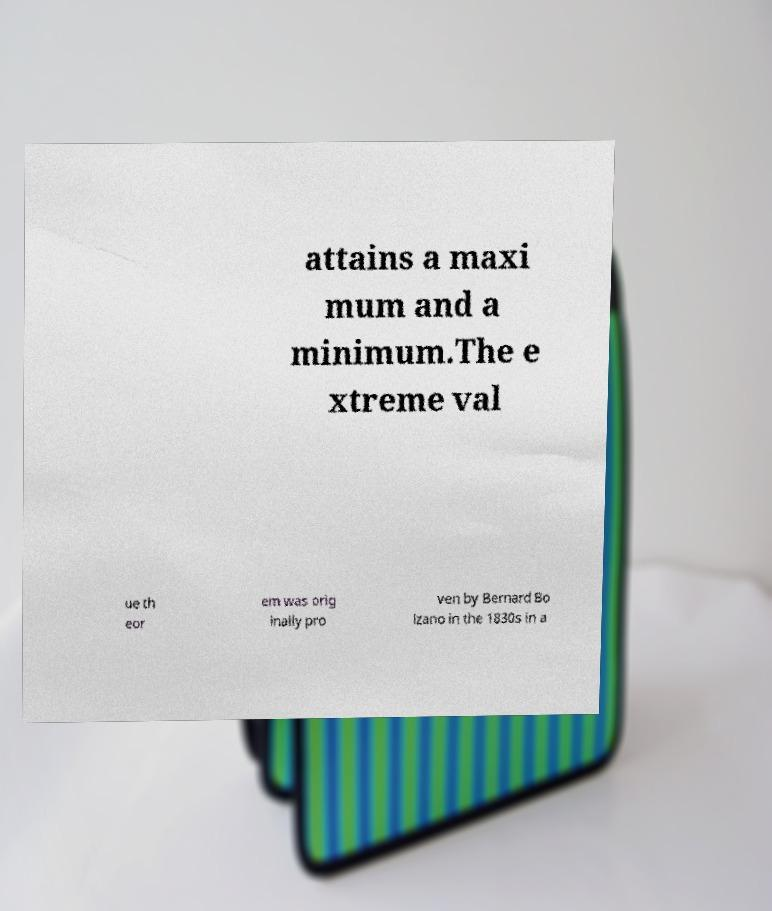Could you extract and type out the text from this image? attains a maxi mum and a minimum.The e xtreme val ue th eor em was orig inally pro ven by Bernard Bo lzano in the 1830s in a 